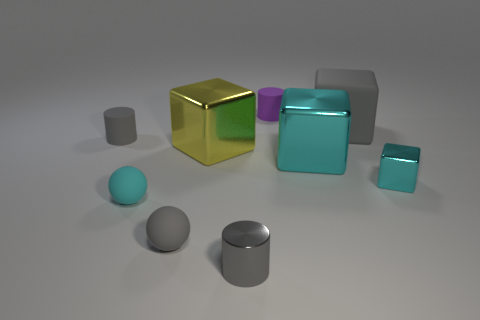There is a gray cylinder on the left side of the big block on the left side of the matte cylinder behind the large rubber block; what size is it? The gray cylinder is small in size compared to the adjacent blocks, and it's positioned on the left side of the larger objects in the scene, partially tucked behind them. Its modest dimensions and unobtrusive placement give it a subtle presence in the arrangement of shapes. 